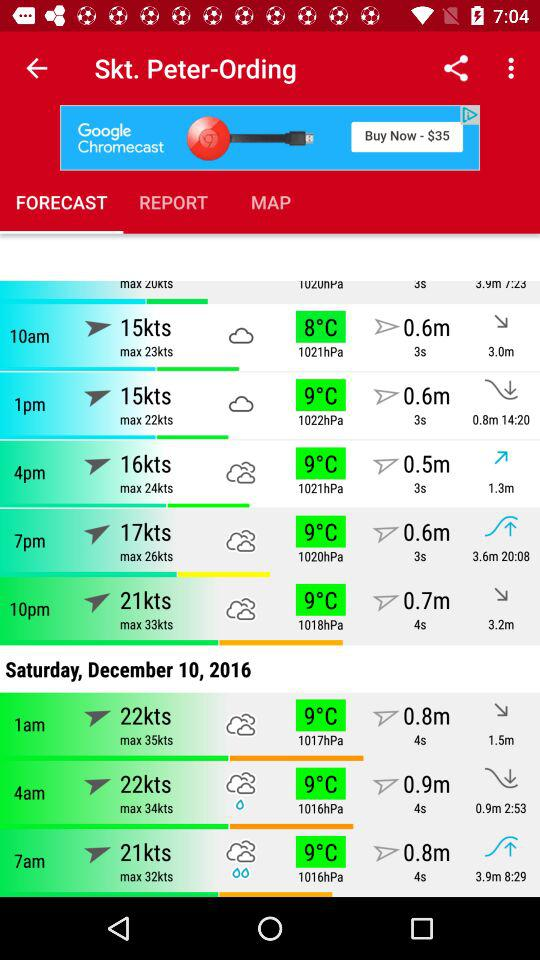How many hours are there between the 1am and 7am timeslots?
Answer the question using a single word or phrase. 6 